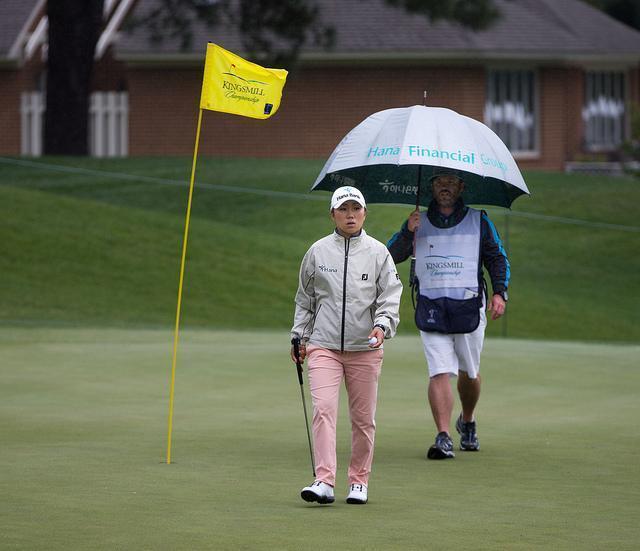What are they doing?
Answer the question by selecting the correct answer among the 4 following choices.
Options: Stealing balls, leaving, arguing, golfing. Golfing. 